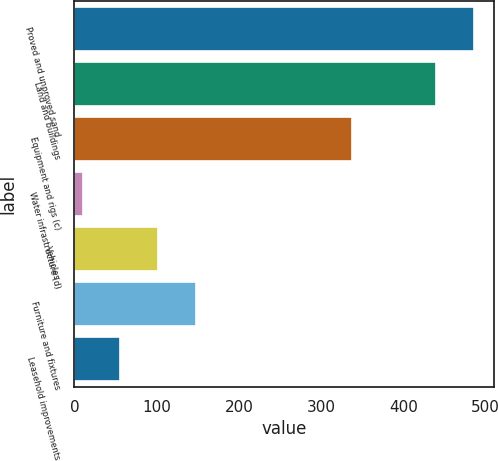Convert chart to OTSL. <chart><loc_0><loc_0><loc_500><loc_500><bar_chart><fcel>Proved and unproved sand<fcel>Land and buildings<fcel>Equipment and rigs (c)<fcel>Water infrastructure (d)<fcel>Vehicles<fcel>Furniture and fixtures<fcel>Leasehold improvements<nl><fcel>485.9<fcel>440<fcel>338<fcel>10<fcel>101.8<fcel>147.7<fcel>55.9<nl></chart> 